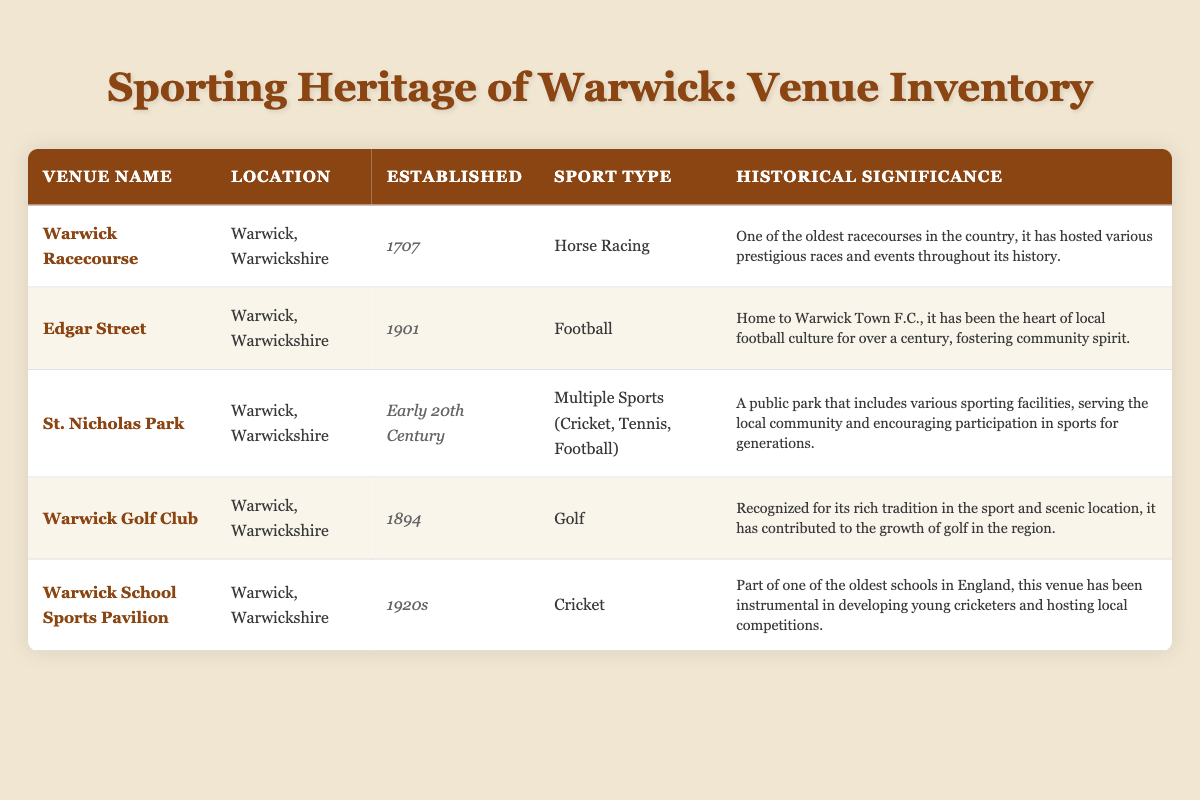What is the established year of Warwick Racecourse? The table shows that Warwick Racecourse was established in the year 1707.
Answer: 1707 Which venue is associated with football? By looking at the sport type column, Edgar Street is specified as the venue for football.
Answer: Edgar Street How many venues were established in the 20th century? The venues from the table established in the 20th century are Edgar Street (1901), St. Nicholas Park (Early 20th Century), and Warwick School Sports Pavilion (1920s). This totals to three venues.
Answer: 3 Is St. Nicholas Park significant for multiple sports? The table indicates that St. Nicholas Park has facilities for cricket, tennis, and football, confirming its significance for multiple sports.
Answer: Yes Which venue has hosted various prestigious races and events? The historical significance of Warwick Racecourse states it has hosted various prestigious races and events throughout its history, which confirms it.
Answer: Warwick Racecourse What year was the Warwick Golf Club established? The table lists the established year of Warwick Golf Club as 1894.
Answer: 1894 Are there any venues established before the 1900s? By examining the established year column, Warwick Racecourse (1707) and Warwick Golf Club (1894) were both established before the 1900s. This confirms there are venues established before that year.
Answer: Yes Could you identify the venue that has been the heart of local football culture? The table describes Edgar Street as the venue that has been the heart of local football culture for over a century, highlighting its significance in local football.
Answer: Edgar Street If we consider the average year of establishment for the venues, what would it be? Calculating the years: Warwick Racecourse (1707), Warwick Golf Club (1894), Edgar Street (1901), St. Nicholas Park (considered as 1920), and Warwick School Sports Pavilion (1925). Adding these gives 1707 + 1894 + 1901 + 1920 + 1925 = 10247. Dividing that by 5 yields an average year of establishment approximately equal to 2049, which, when accounting for decades, is closer to 1900s.
Answer: 1900s 